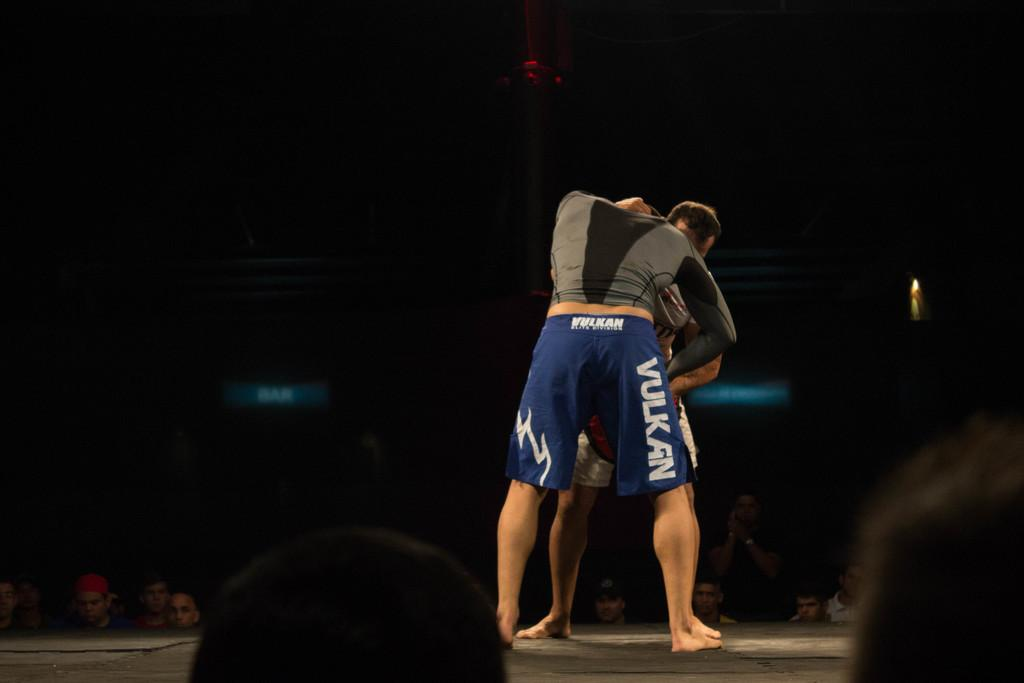<image>
Provide a brief description of the given image. the word vulkan is on the side of the shorts 